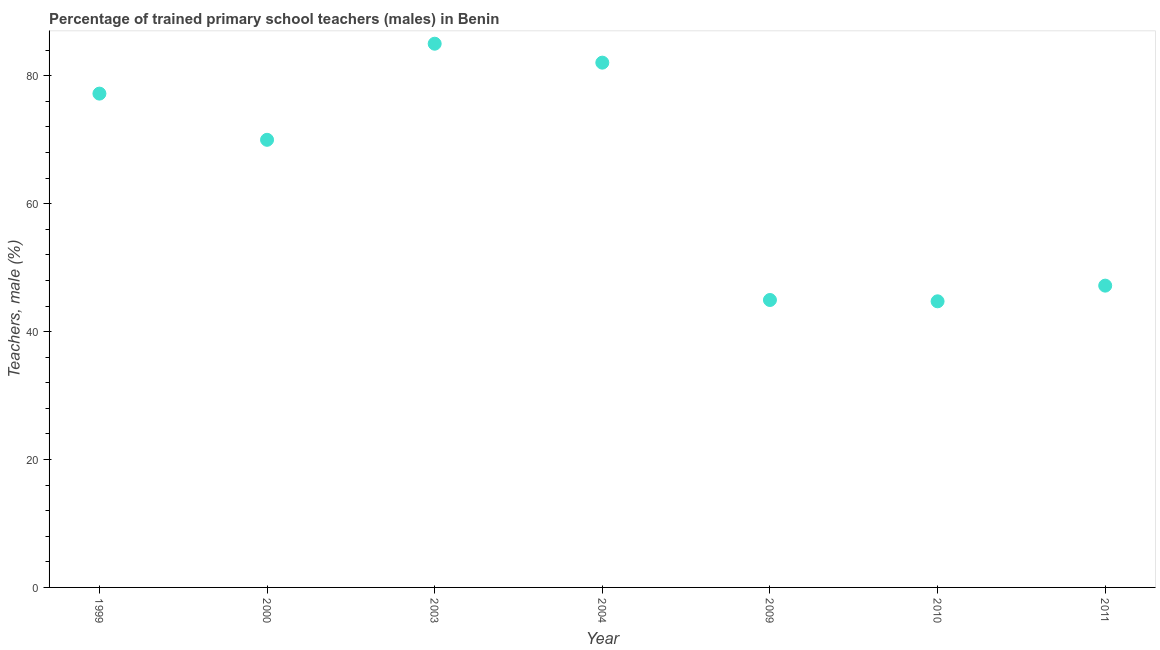What is the percentage of trained male teachers in 2011?
Offer a very short reply. 47.19. Across all years, what is the maximum percentage of trained male teachers?
Offer a terse response. 85.01. Across all years, what is the minimum percentage of trained male teachers?
Provide a short and direct response. 44.74. In which year was the percentage of trained male teachers maximum?
Give a very brief answer. 2003. What is the sum of the percentage of trained male teachers?
Make the answer very short. 451.13. What is the difference between the percentage of trained male teachers in 2000 and 2003?
Give a very brief answer. -15.03. What is the average percentage of trained male teachers per year?
Offer a very short reply. 64.45. What is the median percentage of trained male teachers?
Ensure brevity in your answer.  69.99. What is the ratio of the percentage of trained male teachers in 2003 to that in 2004?
Offer a very short reply. 1.04. Is the difference between the percentage of trained male teachers in 1999 and 2003 greater than the difference between any two years?
Provide a succinct answer. No. What is the difference between the highest and the second highest percentage of trained male teachers?
Your answer should be compact. 2.96. What is the difference between the highest and the lowest percentage of trained male teachers?
Make the answer very short. 40.28. How many dotlines are there?
Give a very brief answer. 1. What is the difference between two consecutive major ticks on the Y-axis?
Your answer should be compact. 20. Are the values on the major ticks of Y-axis written in scientific E-notation?
Ensure brevity in your answer.  No. Does the graph contain any zero values?
Provide a short and direct response. No. What is the title of the graph?
Make the answer very short. Percentage of trained primary school teachers (males) in Benin. What is the label or title of the X-axis?
Your answer should be very brief. Year. What is the label or title of the Y-axis?
Your answer should be very brief. Teachers, male (%). What is the Teachers, male (%) in 1999?
Make the answer very short. 77.21. What is the Teachers, male (%) in 2000?
Ensure brevity in your answer.  69.99. What is the Teachers, male (%) in 2003?
Your response must be concise. 85.01. What is the Teachers, male (%) in 2004?
Your answer should be compact. 82.05. What is the Teachers, male (%) in 2009?
Your response must be concise. 44.94. What is the Teachers, male (%) in 2010?
Provide a succinct answer. 44.74. What is the Teachers, male (%) in 2011?
Your answer should be compact. 47.19. What is the difference between the Teachers, male (%) in 1999 and 2000?
Offer a very short reply. 7.22. What is the difference between the Teachers, male (%) in 1999 and 2003?
Offer a very short reply. -7.8. What is the difference between the Teachers, male (%) in 1999 and 2004?
Provide a short and direct response. -4.84. What is the difference between the Teachers, male (%) in 1999 and 2009?
Ensure brevity in your answer.  32.27. What is the difference between the Teachers, male (%) in 1999 and 2010?
Your answer should be compact. 32.47. What is the difference between the Teachers, male (%) in 1999 and 2011?
Provide a short and direct response. 30.02. What is the difference between the Teachers, male (%) in 2000 and 2003?
Ensure brevity in your answer.  -15.03. What is the difference between the Teachers, male (%) in 2000 and 2004?
Give a very brief answer. -12.06. What is the difference between the Teachers, male (%) in 2000 and 2009?
Offer a terse response. 25.04. What is the difference between the Teachers, male (%) in 2000 and 2010?
Offer a very short reply. 25.25. What is the difference between the Teachers, male (%) in 2000 and 2011?
Make the answer very short. 22.8. What is the difference between the Teachers, male (%) in 2003 and 2004?
Provide a short and direct response. 2.96. What is the difference between the Teachers, male (%) in 2003 and 2009?
Your response must be concise. 40.07. What is the difference between the Teachers, male (%) in 2003 and 2010?
Ensure brevity in your answer.  40.28. What is the difference between the Teachers, male (%) in 2003 and 2011?
Your response must be concise. 37.83. What is the difference between the Teachers, male (%) in 2004 and 2009?
Make the answer very short. 37.11. What is the difference between the Teachers, male (%) in 2004 and 2010?
Give a very brief answer. 37.32. What is the difference between the Teachers, male (%) in 2004 and 2011?
Keep it short and to the point. 34.87. What is the difference between the Teachers, male (%) in 2009 and 2010?
Provide a short and direct response. 0.21. What is the difference between the Teachers, male (%) in 2009 and 2011?
Make the answer very short. -2.24. What is the difference between the Teachers, male (%) in 2010 and 2011?
Provide a short and direct response. -2.45. What is the ratio of the Teachers, male (%) in 1999 to that in 2000?
Offer a very short reply. 1.1. What is the ratio of the Teachers, male (%) in 1999 to that in 2003?
Offer a terse response. 0.91. What is the ratio of the Teachers, male (%) in 1999 to that in 2004?
Your answer should be compact. 0.94. What is the ratio of the Teachers, male (%) in 1999 to that in 2009?
Offer a very short reply. 1.72. What is the ratio of the Teachers, male (%) in 1999 to that in 2010?
Provide a succinct answer. 1.73. What is the ratio of the Teachers, male (%) in 1999 to that in 2011?
Your answer should be very brief. 1.64. What is the ratio of the Teachers, male (%) in 2000 to that in 2003?
Offer a very short reply. 0.82. What is the ratio of the Teachers, male (%) in 2000 to that in 2004?
Your answer should be very brief. 0.85. What is the ratio of the Teachers, male (%) in 2000 to that in 2009?
Your response must be concise. 1.56. What is the ratio of the Teachers, male (%) in 2000 to that in 2010?
Provide a succinct answer. 1.56. What is the ratio of the Teachers, male (%) in 2000 to that in 2011?
Offer a very short reply. 1.48. What is the ratio of the Teachers, male (%) in 2003 to that in 2004?
Provide a short and direct response. 1.04. What is the ratio of the Teachers, male (%) in 2003 to that in 2009?
Ensure brevity in your answer.  1.89. What is the ratio of the Teachers, male (%) in 2003 to that in 2011?
Your answer should be very brief. 1.8. What is the ratio of the Teachers, male (%) in 2004 to that in 2009?
Keep it short and to the point. 1.83. What is the ratio of the Teachers, male (%) in 2004 to that in 2010?
Offer a very short reply. 1.83. What is the ratio of the Teachers, male (%) in 2004 to that in 2011?
Offer a very short reply. 1.74. What is the ratio of the Teachers, male (%) in 2009 to that in 2011?
Your response must be concise. 0.95. What is the ratio of the Teachers, male (%) in 2010 to that in 2011?
Offer a terse response. 0.95. 